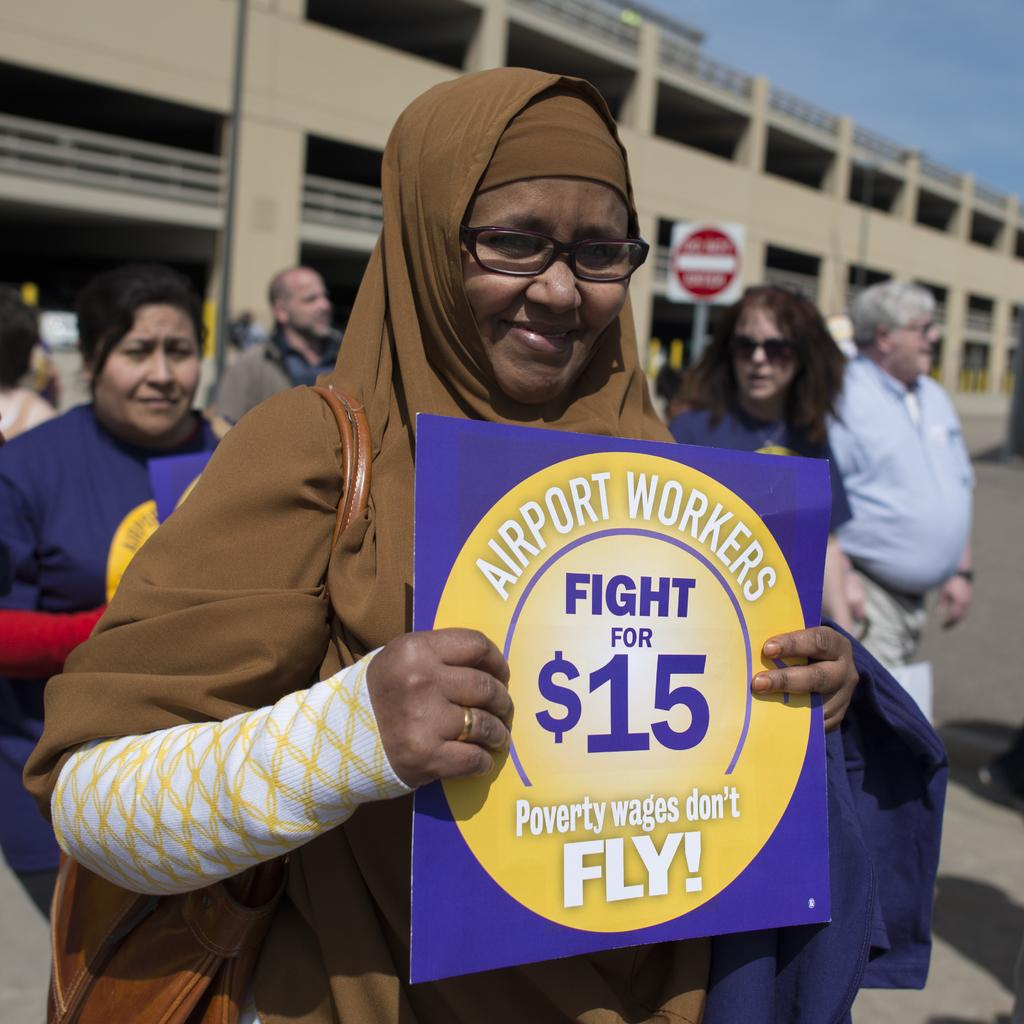Who is the main subject in the image? There is a lady in the image. What is the lady wearing? The lady is wearing a bag. What is the lady holding in the image? The lady is holding a note. Can you describe the note? There is writing on the note. Are there any other people visible in the image? Yes, there are other people behind the lady. What can be seen in the background of the image? There is a building in the background. Can you see a hen flying in the background of the image? There is no hen present in the image, and therefore no such activity can be observed. 